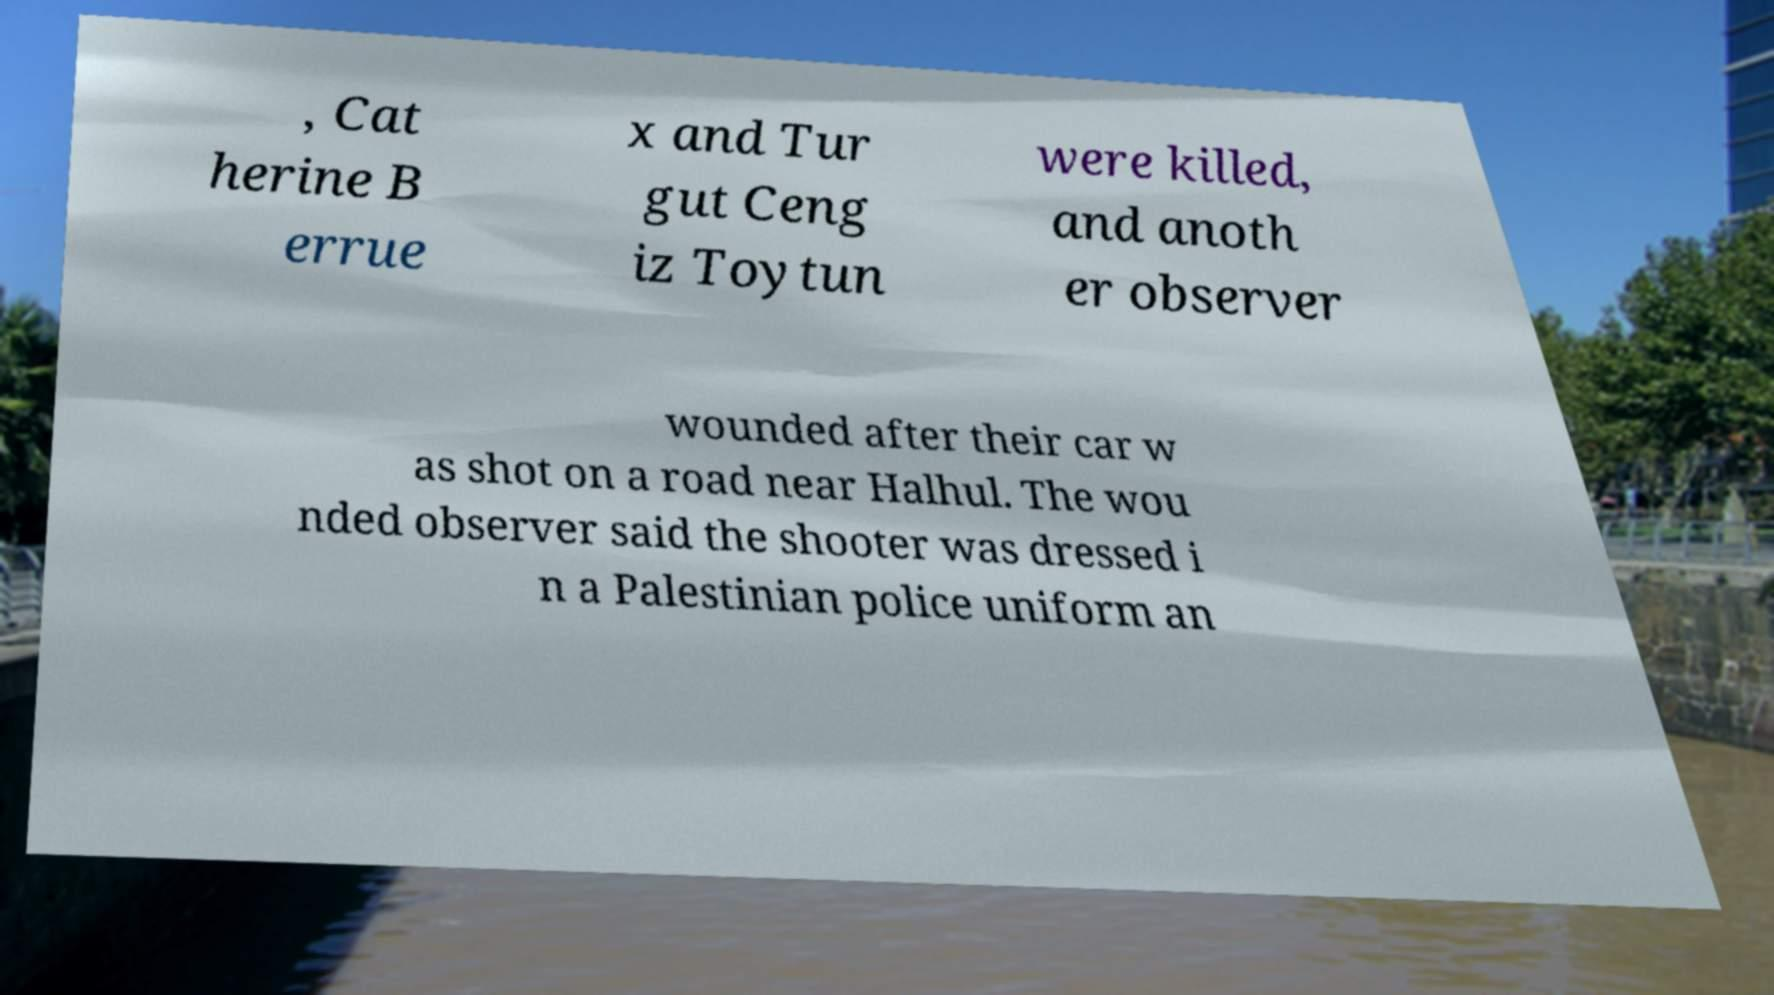For documentation purposes, I need the text within this image transcribed. Could you provide that? , Cat herine B errue x and Tur gut Ceng iz Toytun were killed, and anoth er observer wounded after their car w as shot on a road near Halhul. The wou nded observer said the shooter was dressed i n a Palestinian police uniform an 